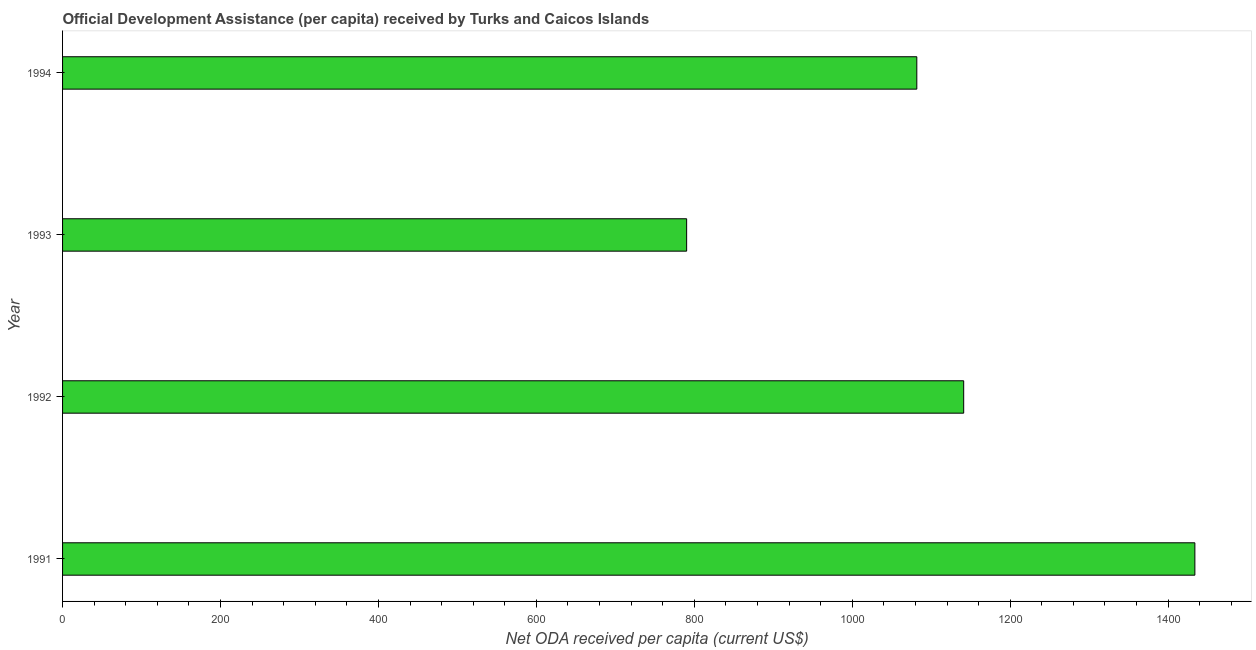What is the title of the graph?
Provide a succinct answer. Official Development Assistance (per capita) received by Turks and Caicos Islands. What is the label or title of the X-axis?
Offer a terse response. Net ODA received per capita (current US$). What is the label or title of the Y-axis?
Your answer should be very brief. Year. What is the net oda received per capita in 1992?
Ensure brevity in your answer.  1141.09. Across all years, what is the maximum net oda received per capita?
Make the answer very short. 1433.84. Across all years, what is the minimum net oda received per capita?
Provide a short and direct response. 790.26. What is the sum of the net oda received per capita?
Give a very brief answer. 4446.92. What is the difference between the net oda received per capita in 1991 and 1992?
Keep it short and to the point. 292.74. What is the average net oda received per capita per year?
Ensure brevity in your answer.  1111.73. What is the median net oda received per capita?
Your response must be concise. 1111.41. In how many years, is the net oda received per capita greater than 880 US$?
Ensure brevity in your answer.  3. Do a majority of the years between 1993 and 1994 (inclusive) have net oda received per capita greater than 1360 US$?
Your response must be concise. No. What is the ratio of the net oda received per capita in 1991 to that in 1993?
Your response must be concise. 1.81. Is the net oda received per capita in 1993 less than that in 1994?
Give a very brief answer. Yes. Is the difference between the net oda received per capita in 1992 and 1994 greater than the difference between any two years?
Offer a terse response. No. What is the difference between the highest and the second highest net oda received per capita?
Your response must be concise. 292.74. Is the sum of the net oda received per capita in 1992 and 1993 greater than the maximum net oda received per capita across all years?
Your answer should be very brief. Yes. What is the difference between the highest and the lowest net oda received per capita?
Keep it short and to the point. 643.58. How many bars are there?
Ensure brevity in your answer.  4. What is the difference between two consecutive major ticks on the X-axis?
Offer a terse response. 200. What is the Net ODA received per capita (current US$) in 1991?
Provide a succinct answer. 1433.84. What is the Net ODA received per capita (current US$) of 1992?
Keep it short and to the point. 1141.09. What is the Net ODA received per capita (current US$) in 1993?
Offer a very short reply. 790.26. What is the Net ODA received per capita (current US$) of 1994?
Offer a very short reply. 1081.73. What is the difference between the Net ODA received per capita (current US$) in 1991 and 1992?
Keep it short and to the point. 292.74. What is the difference between the Net ODA received per capita (current US$) in 1991 and 1993?
Offer a terse response. 643.58. What is the difference between the Net ODA received per capita (current US$) in 1991 and 1994?
Offer a terse response. 352.11. What is the difference between the Net ODA received per capita (current US$) in 1992 and 1993?
Offer a very short reply. 350.84. What is the difference between the Net ODA received per capita (current US$) in 1992 and 1994?
Your answer should be compact. 59.37. What is the difference between the Net ODA received per capita (current US$) in 1993 and 1994?
Your answer should be very brief. -291.47. What is the ratio of the Net ODA received per capita (current US$) in 1991 to that in 1992?
Give a very brief answer. 1.26. What is the ratio of the Net ODA received per capita (current US$) in 1991 to that in 1993?
Offer a terse response. 1.81. What is the ratio of the Net ODA received per capita (current US$) in 1991 to that in 1994?
Offer a terse response. 1.33. What is the ratio of the Net ODA received per capita (current US$) in 1992 to that in 1993?
Give a very brief answer. 1.44. What is the ratio of the Net ODA received per capita (current US$) in 1992 to that in 1994?
Your response must be concise. 1.05. What is the ratio of the Net ODA received per capita (current US$) in 1993 to that in 1994?
Your response must be concise. 0.73. 